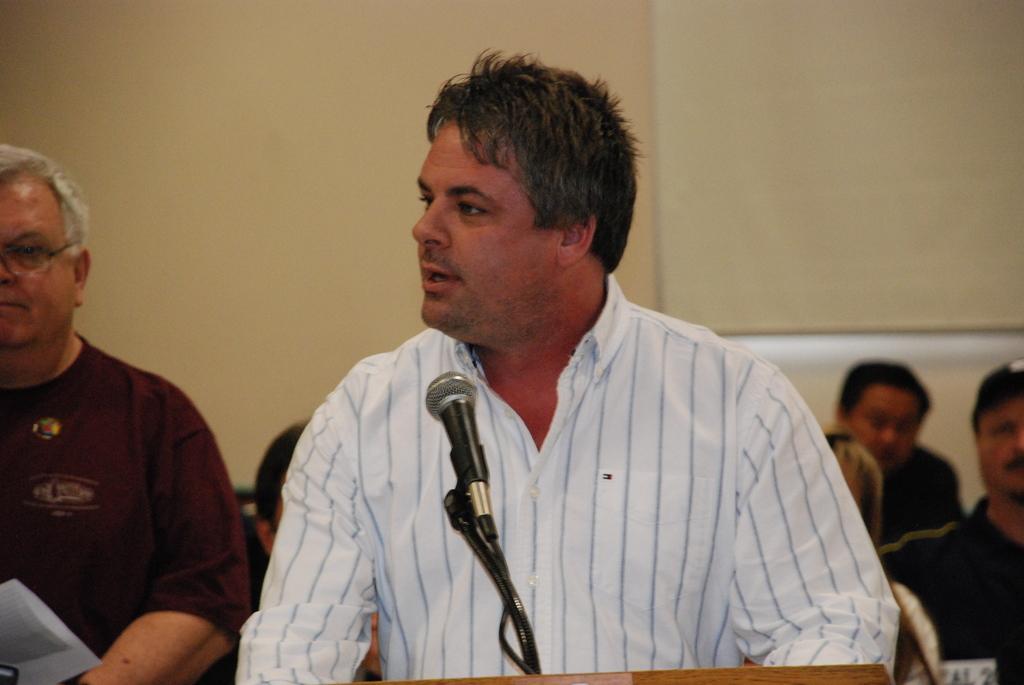Could you give a brief overview of what you see in this image? In this image there is a man in the middle. In front of him there is a mic. In the background there are few other people who are sitting and watching the man. Behind them there is a curtain. 